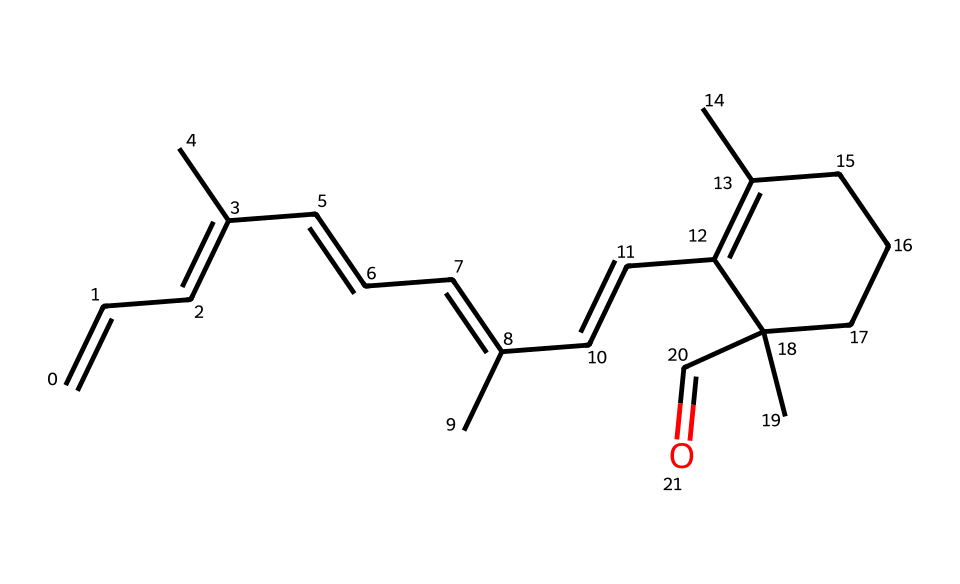What is the functional group present in this compound? The compound has a terminal carbonyl group (C=O) at one end, characteristic of aldehydes.
Answer: aldehyde How many carbon atoms are there in the structure? By counting the explicit carbon atoms from the SMILES representation, there are 20 carbon atoms present in the structure.
Answer: 20 What type of isomerism might be present in this compound? Given the multiple double bonds in the structure, this compound can exhibit geometric isomerism (cis-trans) around the double bonds.
Answer: geometric Which part of this chemical structure gives it the ability to absorb light in low-light conditions? The conjugated system of double bonds and the carbonyl group contribute to the light-absorbing properties, especially in the retinal structure.
Answer: conjugated system How many double bonds are present in the molecule? By analyzing the SMILES notation, there are 6 double bonds indicated in the chemical structure, which include those of the conjugated dienes.
Answer: 6 What role does the aldehyde group play in retinal? The aldehyde group is crucial for the function of retinal in visual processes, particularly as it undergoes isomerization when absorbing light.
Answer: isomerization 